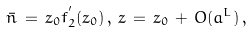<formula> <loc_0><loc_0><loc_500><loc_500>\bar { n } \, = \, z _ { 0 } f ^ { ^ { \prime } } _ { 2 } ( z _ { 0 } ) \, , \, z \, = \, z _ { 0 } \, + \, O ( a ^ { L } ) \, ,</formula> 